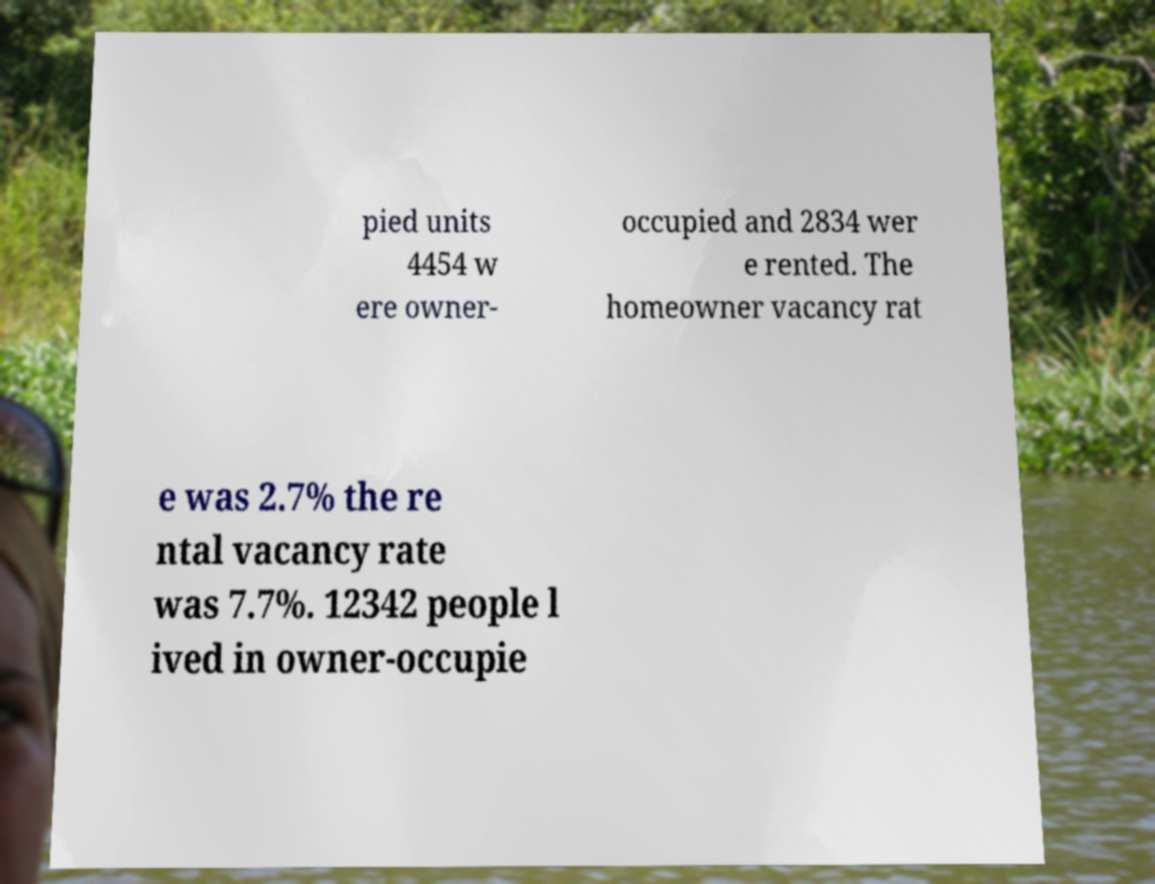Can you read and provide the text displayed in the image?This photo seems to have some interesting text. Can you extract and type it out for me? pied units 4454 w ere owner- occupied and 2834 wer e rented. The homeowner vacancy rat e was 2.7% the re ntal vacancy rate was 7.7%. 12342 people l ived in owner-occupie 